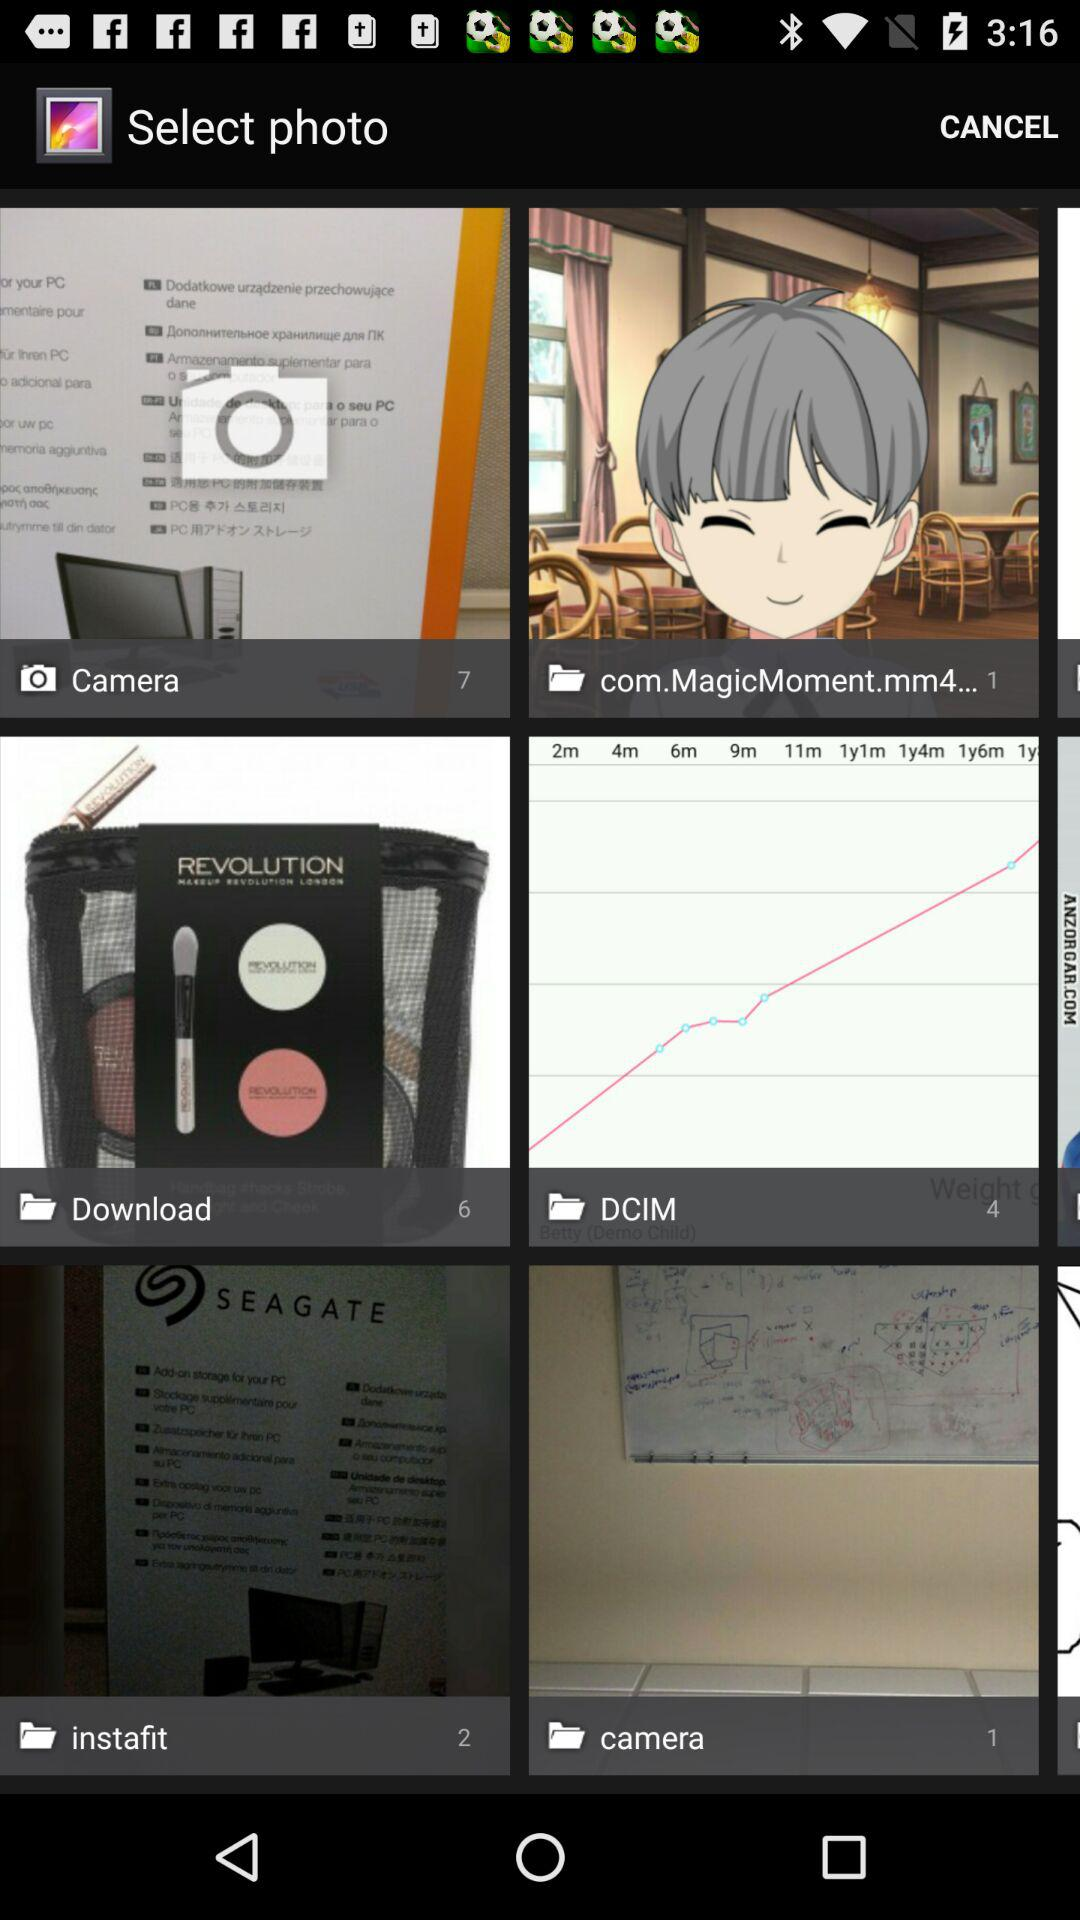How many images are there in the "Download" folder? There are 6 images in the "Download" folder. 